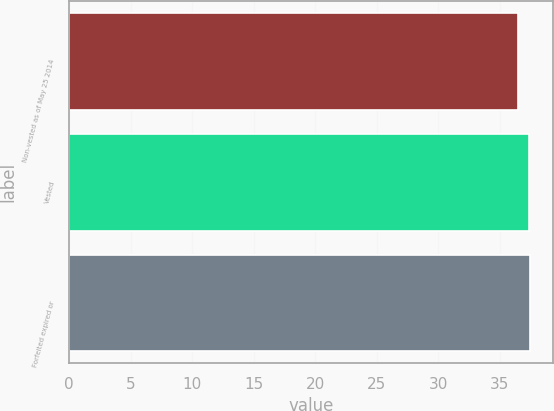Convert chart to OTSL. <chart><loc_0><loc_0><loc_500><loc_500><bar_chart><fcel>Non-vested as of May 25 2014<fcel>Vested<fcel>Forfeited expired or<nl><fcel>36.52<fcel>37.4<fcel>37.49<nl></chart> 